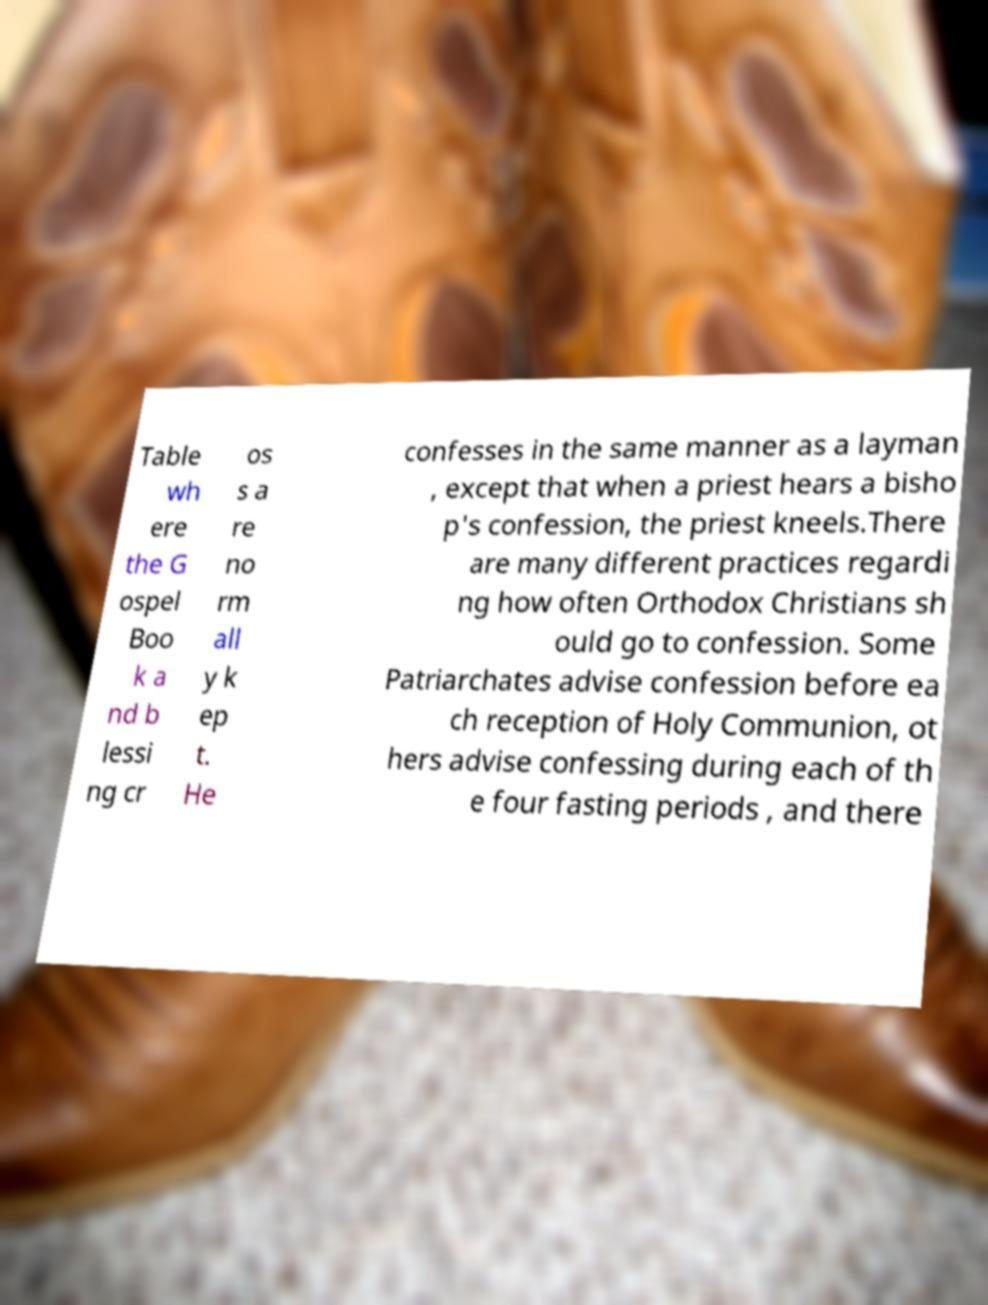I need the written content from this picture converted into text. Can you do that? Table wh ere the G ospel Boo k a nd b lessi ng cr os s a re no rm all y k ep t. He confesses in the same manner as a layman , except that when a priest hears a bisho p's confession, the priest kneels.There are many different practices regardi ng how often Orthodox Christians sh ould go to confession. Some Patriarchates advise confession before ea ch reception of Holy Communion, ot hers advise confessing during each of th e four fasting periods , and there 